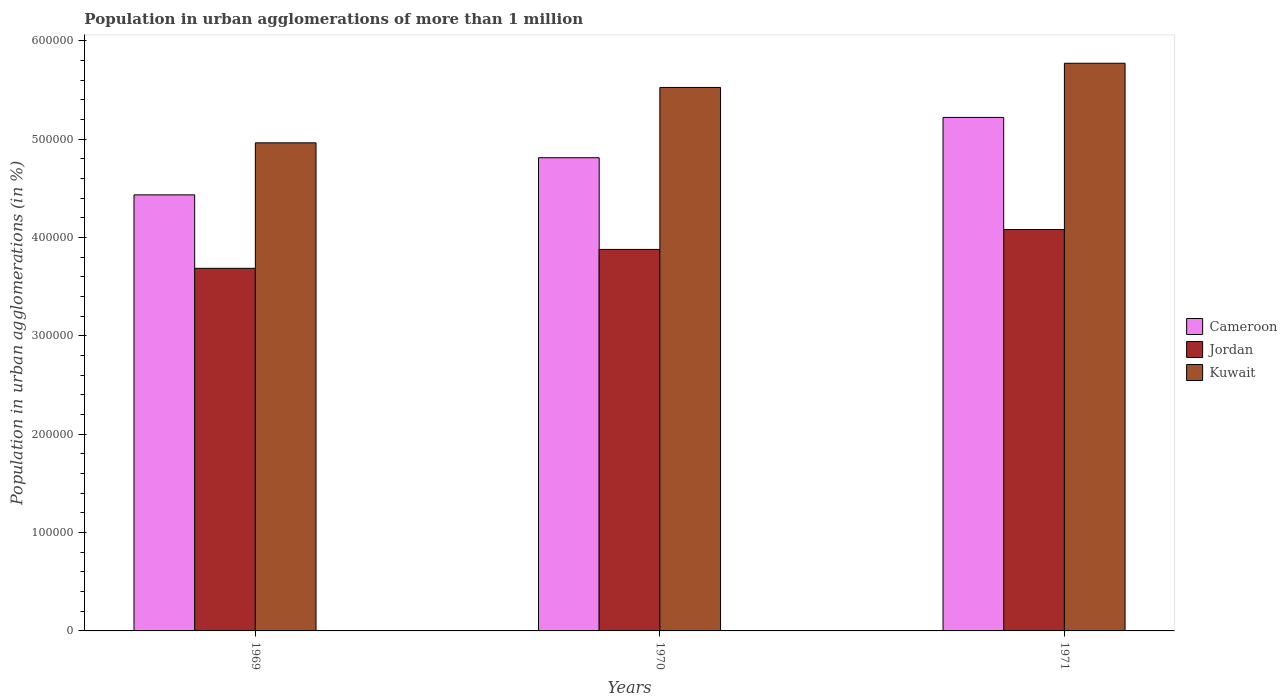How many different coloured bars are there?
Your response must be concise. 3. Are the number of bars per tick equal to the number of legend labels?
Offer a terse response. Yes. How many bars are there on the 1st tick from the right?
Your answer should be compact. 3. What is the label of the 1st group of bars from the left?
Provide a succinct answer. 1969. What is the population in urban agglomerations in Kuwait in 1970?
Your response must be concise. 5.52e+05. Across all years, what is the maximum population in urban agglomerations in Kuwait?
Offer a very short reply. 5.77e+05. Across all years, what is the minimum population in urban agglomerations in Cameroon?
Provide a short and direct response. 4.43e+05. In which year was the population in urban agglomerations in Jordan maximum?
Give a very brief answer. 1971. In which year was the population in urban agglomerations in Cameroon minimum?
Give a very brief answer. 1969. What is the total population in urban agglomerations in Kuwait in the graph?
Offer a terse response. 1.63e+06. What is the difference between the population in urban agglomerations in Jordan in 1970 and that in 1971?
Give a very brief answer. -2.02e+04. What is the difference between the population in urban agglomerations in Kuwait in 1969 and the population in urban agglomerations in Cameroon in 1970?
Provide a short and direct response. 1.51e+04. What is the average population in urban agglomerations in Jordan per year?
Your response must be concise. 3.88e+05. In the year 1969, what is the difference between the population in urban agglomerations in Cameroon and population in urban agglomerations in Kuwait?
Your answer should be compact. -5.29e+04. What is the ratio of the population in urban agglomerations in Cameroon in 1969 to that in 1970?
Ensure brevity in your answer.  0.92. What is the difference between the highest and the second highest population in urban agglomerations in Cameroon?
Keep it short and to the point. 4.10e+04. What is the difference between the highest and the lowest population in urban agglomerations in Jordan?
Offer a very short reply. 3.94e+04. In how many years, is the population in urban agglomerations in Cameroon greater than the average population in urban agglomerations in Cameroon taken over all years?
Offer a very short reply. 1. What does the 1st bar from the left in 1971 represents?
Provide a succinct answer. Cameroon. What does the 3rd bar from the right in 1971 represents?
Ensure brevity in your answer.  Cameroon. What is the difference between two consecutive major ticks on the Y-axis?
Offer a terse response. 1.00e+05. Are the values on the major ticks of Y-axis written in scientific E-notation?
Offer a very short reply. No. Where does the legend appear in the graph?
Provide a succinct answer. Center right. What is the title of the graph?
Give a very brief answer. Population in urban agglomerations of more than 1 million. What is the label or title of the X-axis?
Your answer should be very brief. Years. What is the label or title of the Y-axis?
Keep it short and to the point. Population in urban agglomerations (in %). What is the Population in urban agglomerations (in %) of Cameroon in 1969?
Ensure brevity in your answer.  4.43e+05. What is the Population in urban agglomerations (in %) in Jordan in 1969?
Provide a succinct answer. 3.69e+05. What is the Population in urban agglomerations (in %) of Kuwait in 1969?
Make the answer very short. 4.96e+05. What is the Population in urban agglomerations (in %) of Cameroon in 1970?
Ensure brevity in your answer.  4.81e+05. What is the Population in urban agglomerations (in %) in Jordan in 1970?
Your answer should be very brief. 3.88e+05. What is the Population in urban agglomerations (in %) in Kuwait in 1970?
Provide a succinct answer. 5.52e+05. What is the Population in urban agglomerations (in %) in Cameroon in 1971?
Keep it short and to the point. 5.22e+05. What is the Population in urban agglomerations (in %) of Jordan in 1971?
Provide a short and direct response. 4.08e+05. What is the Population in urban agglomerations (in %) of Kuwait in 1971?
Your answer should be compact. 5.77e+05. Across all years, what is the maximum Population in urban agglomerations (in %) in Cameroon?
Keep it short and to the point. 5.22e+05. Across all years, what is the maximum Population in urban agglomerations (in %) in Jordan?
Offer a very short reply. 4.08e+05. Across all years, what is the maximum Population in urban agglomerations (in %) in Kuwait?
Offer a very short reply. 5.77e+05. Across all years, what is the minimum Population in urban agglomerations (in %) in Cameroon?
Provide a succinct answer. 4.43e+05. Across all years, what is the minimum Population in urban agglomerations (in %) in Jordan?
Ensure brevity in your answer.  3.69e+05. Across all years, what is the minimum Population in urban agglomerations (in %) of Kuwait?
Give a very brief answer. 4.96e+05. What is the total Population in urban agglomerations (in %) of Cameroon in the graph?
Your answer should be very brief. 1.45e+06. What is the total Population in urban agglomerations (in %) of Jordan in the graph?
Provide a succinct answer. 1.16e+06. What is the total Population in urban agglomerations (in %) of Kuwait in the graph?
Keep it short and to the point. 1.63e+06. What is the difference between the Population in urban agglomerations (in %) in Cameroon in 1969 and that in 1970?
Your answer should be compact. -3.77e+04. What is the difference between the Population in urban agglomerations (in %) of Jordan in 1969 and that in 1970?
Provide a succinct answer. -1.92e+04. What is the difference between the Population in urban agglomerations (in %) of Kuwait in 1969 and that in 1970?
Make the answer very short. -5.63e+04. What is the difference between the Population in urban agglomerations (in %) of Cameroon in 1969 and that in 1971?
Offer a very short reply. -7.87e+04. What is the difference between the Population in urban agglomerations (in %) in Jordan in 1969 and that in 1971?
Make the answer very short. -3.94e+04. What is the difference between the Population in urban agglomerations (in %) in Kuwait in 1969 and that in 1971?
Give a very brief answer. -8.09e+04. What is the difference between the Population in urban agglomerations (in %) in Cameroon in 1970 and that in 1971?
Your response must be concise. -4.10e+04. What is the difference between the Population in urban agglomerations (in %) in Jordan in 1970 and that in 1971?
Make the answer very short. -2.02e+04. What is the difference between the Population in urban agglomerations (in %) in Kuwait in 1970 and that in 1971?
Provide a short and direct response. -2.46e+04. What is the difference between the Population in urban agglomerations (in %) in Cameroon in 1969 and the Population in urban agglomerations (in %) in Jordan in 1970?
Your answer should be compact. 5.55e+04. What is the difference between the Population in urban agglomerations (in %) of Cameroon in 1969 and the Population in urban agglomerations (in %) of Kuwait in 1970?
Your answer should be very brief. -1.09e+05. What is the difference between the Population in urban agglomerations (in %) in Jordan in 1969 and the Population in urban agglomerations (in %) in Kuwait in 1970?
Your response must be concise. -1.84e+05. What is the difference between the Population in urban agglomerations (in %) of Cameroon in 1969 and the Population in urban agglomerations (in %) of Jordan in 1971?
Provide a succinct answer. 3.53e+04. What is the difference between the Population in urban agglomerations (in %) of Cameroon in 1969 and the Population in urban agglomerations (in %) of Kuwait in 1971?
Your answer should be very brief. -1.34e+05. What is the difference between the Population in urban agglomerations (in %) in Jordan in 1969 and the Population in urban agglomerations (in %) in Kuwait in 1971?
Ensure brevity in your answer.  -2.08e+05. What is the difference between the Population in urban agglomerations (in %) of Cameroon in 1970 and the Population in urban agglomerations (in %) of Jordan in 1971?
Provide a short and direct response. 7.30e+04. What is the difference between the Population in urban agglomerations (in %) in Cameroon in 1970 and the Population in urban agglomerations (in %) in Kuwait in 1971?
Offer a terse response. -9.60e+04. What is the difference between the Population in urban agglomerations (in %) of Jordan in 1970 and the Population in urban agglomerations (in %) of Kuwait in 1971?
Keep it short and to the point. -1.89e+05. What is the average Population in urban agglomerations (in %) in Cameroon per year?
Your answer should be very brief. 4.82e+05. What is the average Population in urban agglomerations (in %) in Jordan per year?
Ensure brevity in your answer.  3.88e+05. What is the average Population in urban agglomerations (in %) in Kuwait per year?
Offer a very short reply. 5.42e+05. In the year 1969, what is the difference between the Population in urban agglomerations (in %) in Cameroon and Population in urban agglomerations (in %) in Jordan?
Your answer should be compact. 7.47e+04. In the year 1969, what is the difference between the Population in urban agglomerations (in %) of Cameroon and Population in urban agglomerations (in %) of Kuwait?
Your answer should be very brief. -5.29e+04. In the year 1969, what is the difference between the Population in urban agglomerations (in %) in Jordan and Population in urban agglomerations (in %) in Kuwait?
Offer a terse response. -1.28e+05. In the year 1970, what is the difference between the Population in urban agglomerations (in %) of Cameroon and Population in urban agglomerations (in %) of Jordan?
Make the answer very short. 9.32e+04. In the year 1970, what is the difference between the Population in urban agglomerations (in %) of Cameroon and Population in urban agglomerations (in %) of Kuwait?
Your answer should be very brief. -7.14e+04. In the year 1970, what is the difference between the Population in urban agglomerations (in %) of Jordan and Population in urban agglomerations (in %) of Kuwait?
Offer a very short reply. -1.65e+05. In the year 1971, what is the difference between the Population in urban agglomerations (in %) in Cameroon and Population in urban agglomerations (in %) in Jordan?
Provide a short and direct response. 1.14e+05. In the year 1971, what is the difference between the Population in urban agglomerations (in %) of Cameroon and Population in urban agglomerations (in %) of Kuwait?
Give a very brief answer. -5.51e+04. In the year 1971, what is the difference between the Population in urban agglomerations (in %) in Jordan and Population in urban agglomerations (in %) in Kuwait?
Make the answer very short. -1.69e+05. What is the ratio of the Population in urban agglomerations (in %) in Cameroon in 1969 to that in 1970?
Keep it short and to the point. 0.92. What is the ratio of the Population in urban agglomerations (in %) of Jordan in 1969 to that in 1970?
Make the answer very short. 0.95. What is the ratio of the Population in urban agglomerations (in %) of Kuwait in 1969 to that in 1970?
Keep it short and to the point. 0.9. What is the ratio of the Population in urban agglomerations (in %) in Cameroon in 1969 to that in 1971?
Ensure brevity in your answer.  0.85. What is the ratio of the Population in urban agglomerations (in %) in Jordan in 1969 to that in 1971?
Keep it short and to the point. 0.9. What is the ratio of the Population in urban agglomerations (in %) of Kuwait in 1969 to that in 1971?
Offer a terse response. 0.86. What is the ratio of the Population in urban agglomerations (in %) in Cameroon in 1970 to that in 1971?
Offer a terse response. 0.92. What is the ratio of the Population in urban agglomerations (in %) in Jordan in 1970 to that in 1971?
Provide a short and direct response. 0.95. What is the ratio of the Population in urban agglomerations (in %) in Kuwait in 1970 to that in 1971?
Give a very brief answer. 0.96. What is the difference between the highest and the second highest Population in urban agglomerations (in %) in Cameroon?
Give a very brief answer. 4.10e+04. What is the difference between the highest and the second highest Population in urban agglomerations (in %) in Jordan?
Your answer should be compact. 2.02e+04. What is the difference between the highest and the second highest Population in urban agglomerations (in %) of Kuwait?
Keep it short and to the point. 2.46e+04. What is the difference between the highest and the lowest Population in urban agglomerations (in %) of Cameroon?
Provide a short and direct response. 7.87e+04. What is the difference between the highest and the lowest Population in urban agglomerations (in %) in Jordan?
Ensure brevity in your answer.  3.94e+04. What is the difference between the highest and the lowest Population in urban agglomerations (in %) of Kuwait?
Keep it short and to the point. 8.09e+04. 